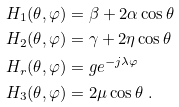<formula> <loc_0><loc_0><loc_500><loc_500>H _ { 1 } ( \theta , \varphi ) & = \beta + 2 \alpha \cos \theta \\ H _ { 2 } ( \theta , \varphi ) & = \gamma + 2 \eta \cos \theta \\ H _ { r } ( \theta , \varphi ) & = g e ^ { - j \lambda \varphi } \\ H _ { 3 } ( \theta , \varphi ) & = 2 \mu \cos \theta \ .</formula> 